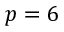<formula> <loc_0><loc_0><loc_500><loc_500>p = 6</formula> 